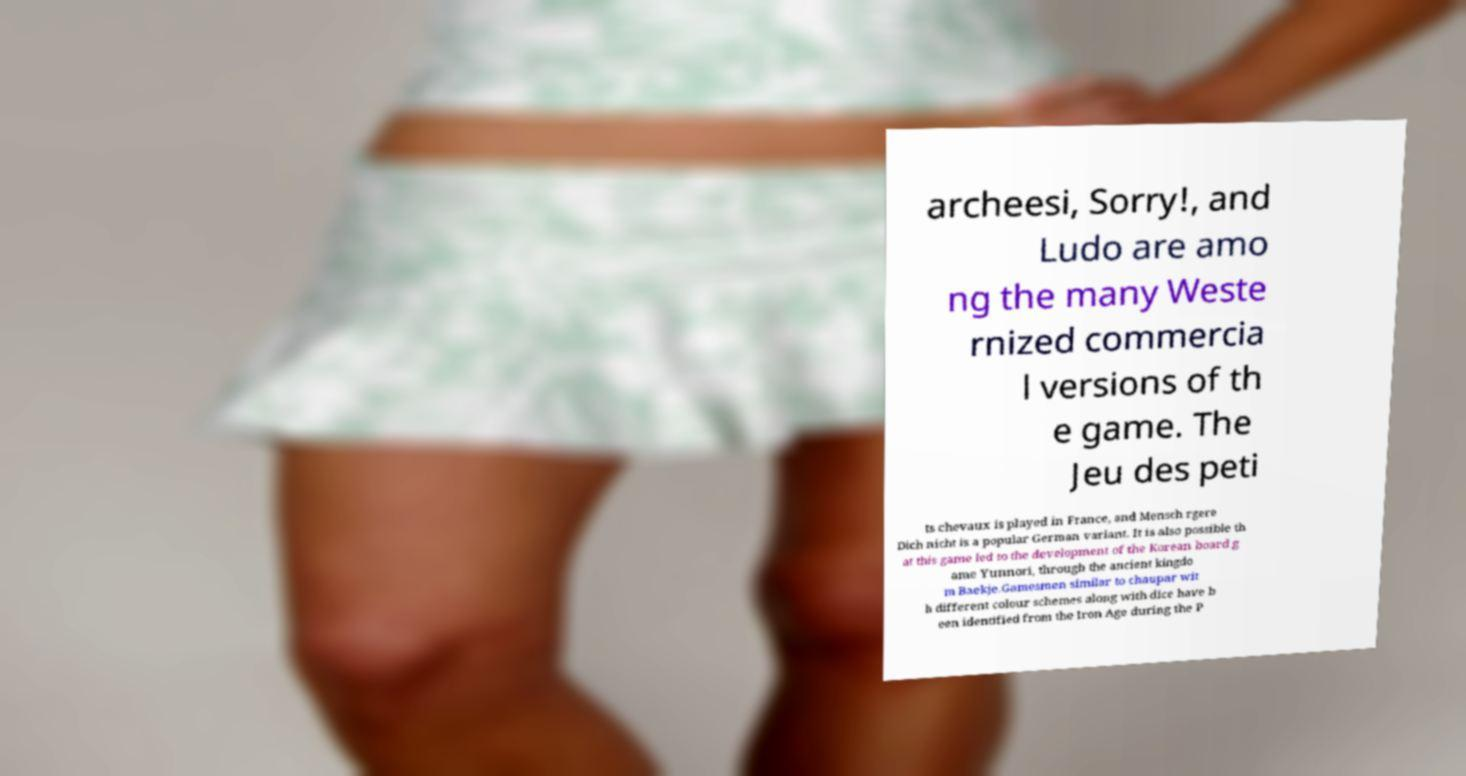Please identify and transcribe the text found in this image. archeesi, Sorry!, and Ludo are amo ng the many Weste rnized commercia l versions of th e game. The Jeu des peti ts chevaux is played in France, and Mensch rgere Dich nicht is a popular German variant. It is also possible th at this game led to the development of the Korean board g ame Yunnori, through the ancient kingdo m Baekje.Gamesmen similar to chaupar wit h different colour schemes along with dice have b een identified from the Iron Age during the P 